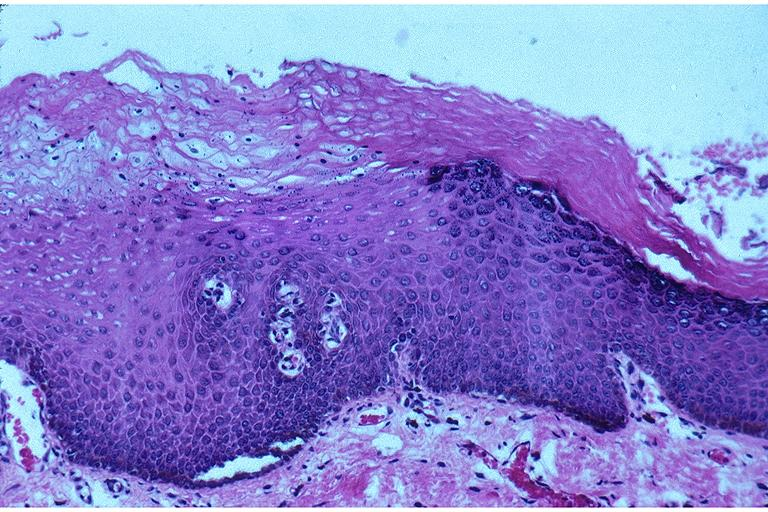what does this image show?
Answer the question using a single word or phrase. Epithelial hyperplasia and hyperkeratosis 